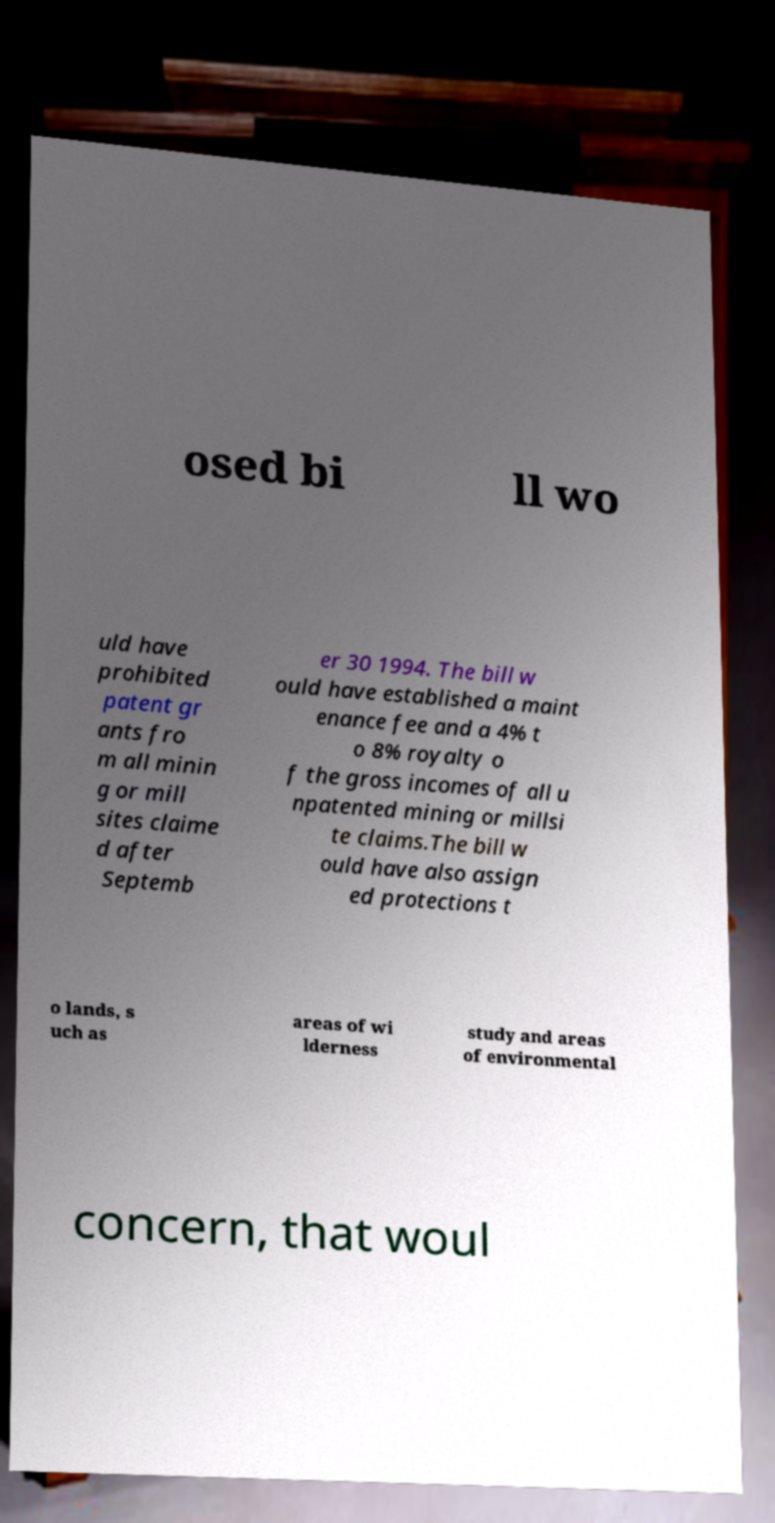Can you accurately transcribe the text from the provided image for me? osed bi ll wo uld have prohibited patent gr ants fro m all minin g or mill sites claime d after Septemb er 30 1994. The bill w ould have established a maint enance fee and a 4% t o 8% royalty o f the gross incomes of all u npatented mining or millsi te claims.The bill w ould have also assign ed protections t o lands, s uch as areas of wi lderness study and areas of environmental concern, that woul 